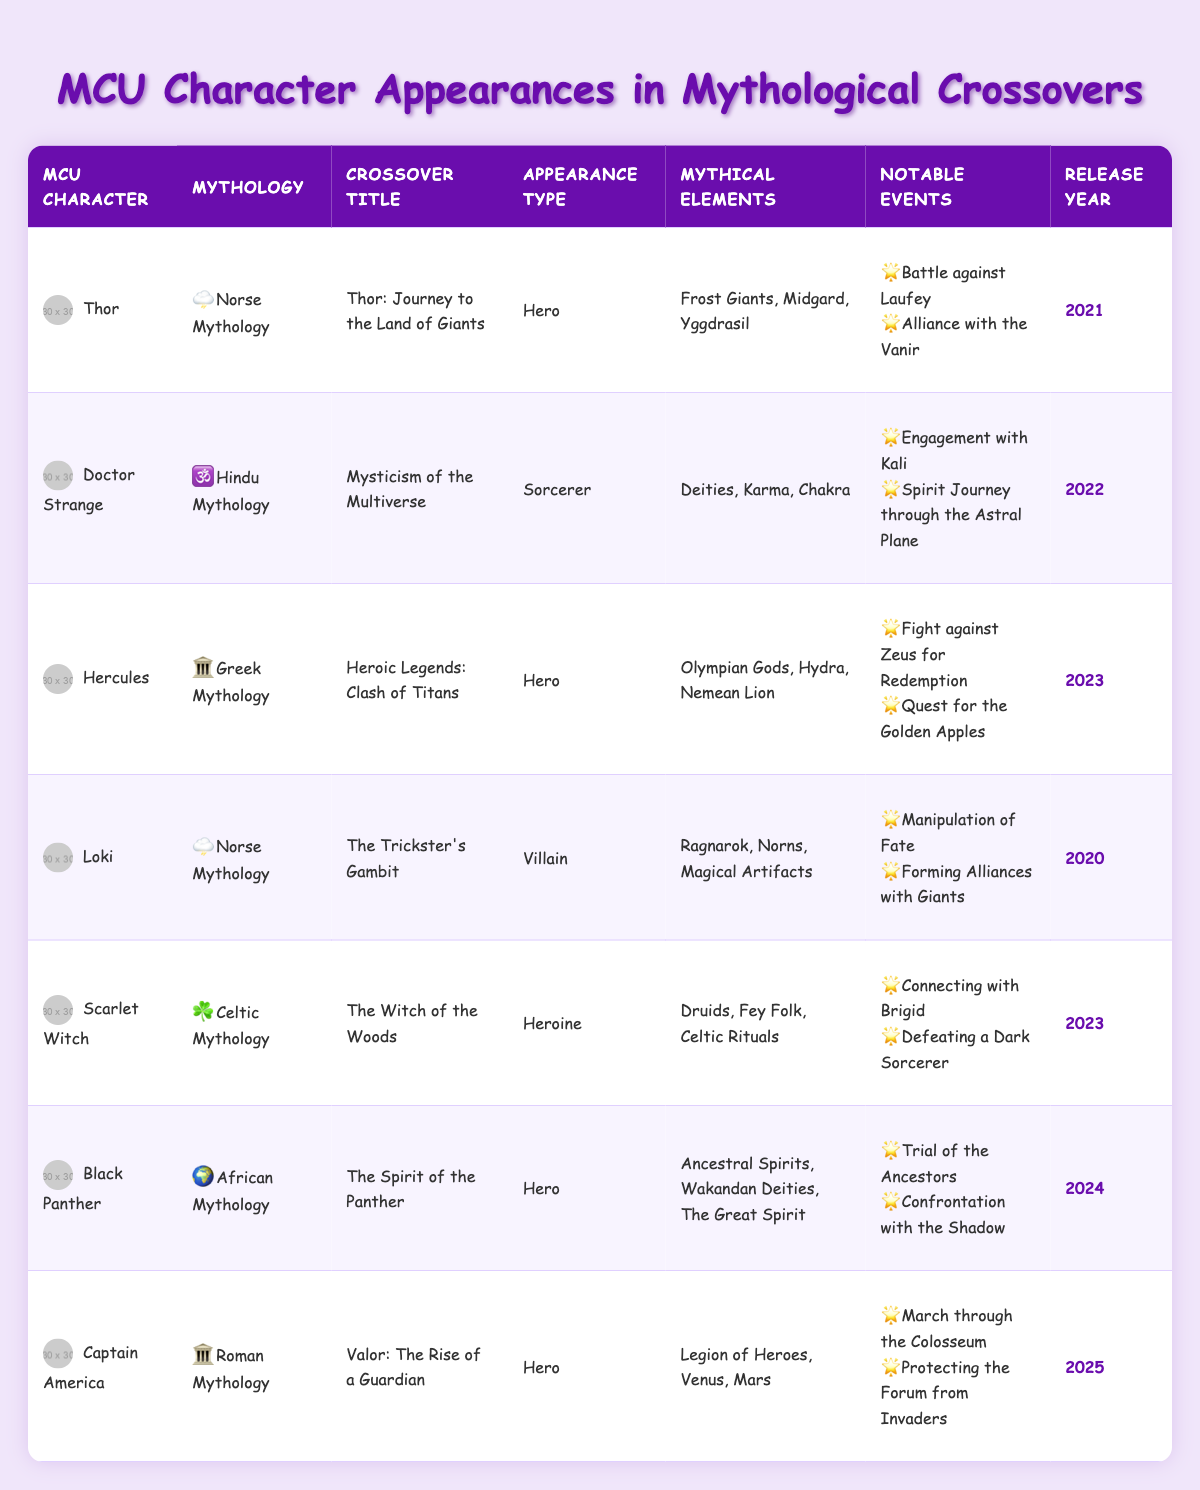What is the crossover title for Thor? The table shows that Thor appears in "Thor: Journey to the Land of Giants." This information can be found directly under the "Crossover Title" column for Thor.
Answer: Thor: Journey to the Land of Giants Which character has an appearance type of Villain? Looking at the "Appearance Type" column, Loki is listed as a Villain, which is the only character with this designation in the table.
Answer: Loki How many different mythologies are represented in the crossover titles? By examining the "Mythology" column, we can see that there are 6 different mythologies: Norse, Hindu, Greek, Celtic, African, and Roman. This means there are 6 distinct mythologies in total.
Answer: 6 What notable event is associated with Scarlet Witch's crossover? Scarlet Witch's notable events include "Connecting with Brigid" and "Defeating a Dark Sorcerer," both listed under the "Notable Events" column next to her.
Answer: Connecting with Brigid Is Black Panther's crossover set in African Mythology? The table indicates that Black Panther's crossover is in the "Mythology" column, which lists African Mythology, confirming that this statement is true.
Answer: Yes Which character's crossover title is associated with the Hydra? The table lists Hercules in "Heroic Legends: Clash of Titans," with notable mythical elements that include the Hydra. Thus, Hercules is the character associated with that.
Answer: Hercules What is the release year for Captain America’s crossover? The "Release Year" column reveals that Captain America appears in a crossover titled "Valor: The Rise of a Guardian" which is set to be released in 2025.
Answer: 2025 Which character appears as a Heroine? Looking at the "Appearance Type" column, Scarlet Witch is the only character defined as a Heroine, making her the sole representative in that category.
Answer: Scarlet Witch If we consider the years of release for these crossovers, which year has the most recent crossover? By checking the "Release Year" column, we see the latest year mentioned is 2025 for Captain America, making it the most recent crossover year in the table.
Answer: 2025 